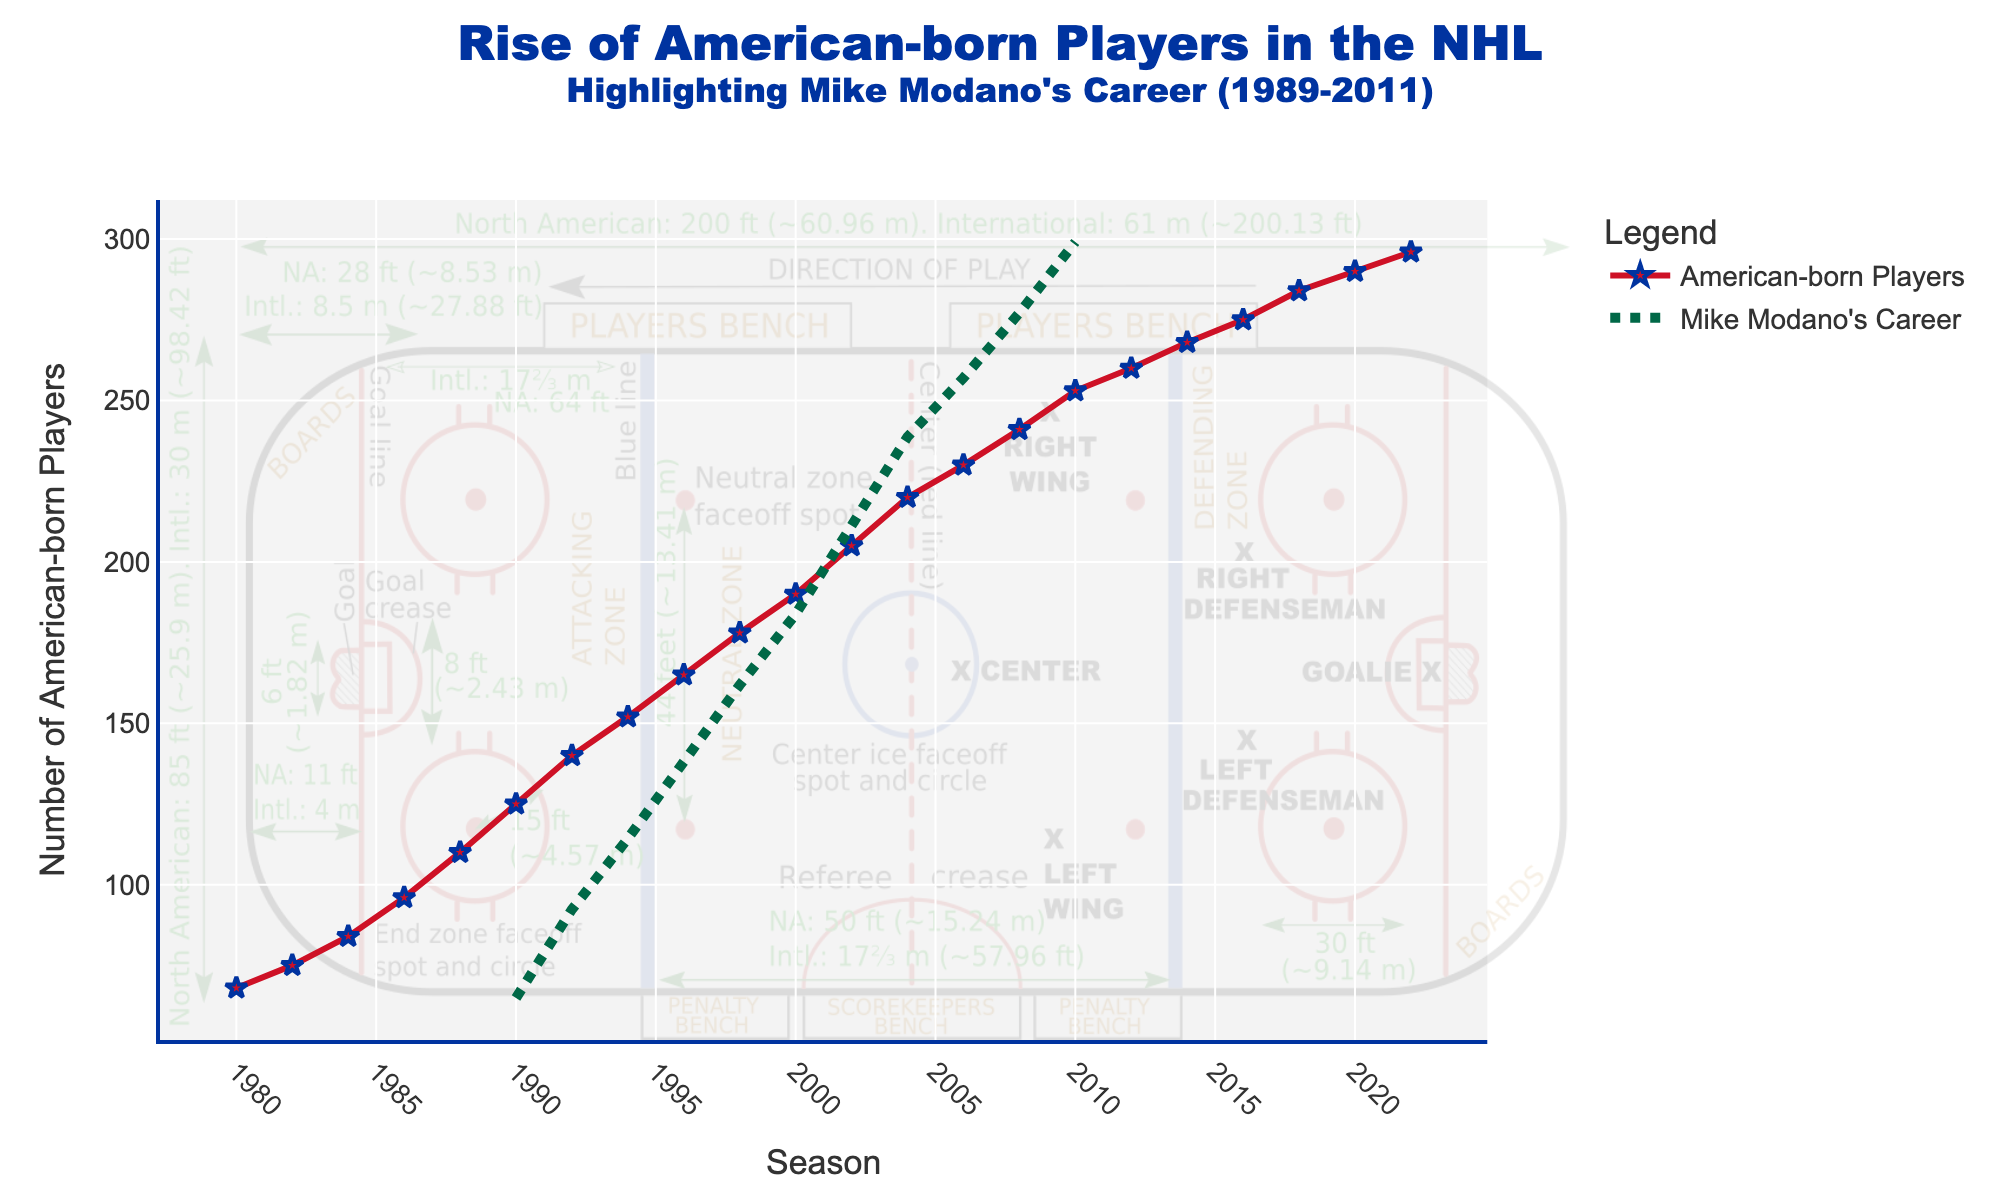What season shows the highest number of American-born players? The highest point on the line chart indicates the season with the most American-born players. The peak value on the chart is in the 2022-23 season.
Answer: 2022-23 How many American-born players were there in the 1984-85 season? Look for the data point labeled 1984-85 on the x-axis and find its corresponding y-axis value. For the season 1984-85, the y-axis value is 84.
Answer: 84 During which span of years did Mike Modano's career overlap with the rise of American-born players? Identify the line that indicates Mike Modano's career; it spans from the first highlighted point in 1989 to the last highlighted point in 2011.
Answer: 1989-2011 How much did the number of American-born players increase from the 1980-81 season to the 2022-23 season? Subtract the number of players in the 1980-81 season from the number of players in the 2022-23 season. It's 296 - 68 = 228.
Answer: 228 Compare the number of American-born players in the 2002-03 and 2012-13 seasons. Which season had more players? Locate the data points for the 2002-03 and 2012-13 seasons and compare their y-axis values. The 2012-13 season had 260 players, whereas the 2002-03 season had 205 players, so 2012-13 had more players.
Answer: 2012-13 Between 1980-81 and 2022-23, in which decade did American-born NHL players increase the most? Break down the data into decades and calculate the difference in the number of players from the start to the end of each decade. The largest increase is in the 1980s, where it went from 68 to 125, an increase of 125 - 68 = 57.
Answer: 1980s What was the average number of American-born players in the NHL during Mike Modano's career (1989-2011)? Average is calculated by summing the values for the years 1989 to 2011 and then dividing by the number of these seasons. Summing up (110+125+140+152+165+178+190+205+220+230+241+253) = 2309 and dividing by 12 gives 2309 / 12 ≈ 192.4.
Answer: 192.4 How does the visual marker for Mike Modano's career compare to the markers for the American-born players in terms of style? The markers for American-born players are represented by red-colored lines with markers, while Mike Modano's career is shown with a green dashed line.
Answer: Red lines with markers, green dashed line From 2008-09 to 2010-11, how many American-born players were added to the NHL? Subtract the number of players in the 2008-09 season from the number of players in the 2010-11 season. It is 253 - 241 = 12.
Answer: 12 During Mike Modano's career, which year had the highest number of American-born players and what was that number? Identify the highest point within the span of Modano's career (1989-2011). This occurred in the 2010-11 season, with 253 players.
Answer: 2010-11, 253 